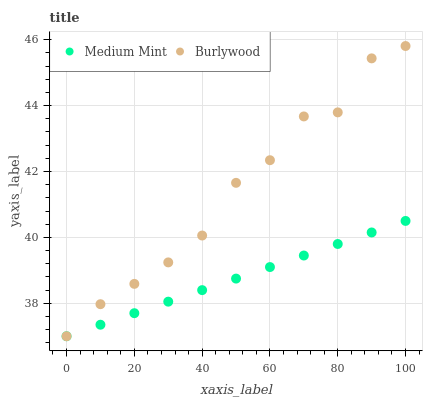Does Medium Mint have the minimum area under the curve?
Answer yes or no. Yes. Does Burlywood have the maximum area under the curve?
Answer yes or no. Yes. Does Burlywood have the minimum area under the curve?
Answer yes or no. No. Is Medium Mint the smoothest?
Answer yes or no. Yes. Is Burlywood the roughest?
Answer yes or no. Yes. Is Burlywood the smoothest?
Answer yes or no. No. Does Medium Mint have the lowest value?
Answer yes or no. Yes. Does Burlywood have the highest value?
Answer yes or no. Yes. Does Medium Mint intersect Burlywood?
Answer yes or no. Yes. Is Medium Mint less than Burlywood?
Answer yes or no. No. Is Medium Mint greater than Burlywood?
Answer yes or no. No. 